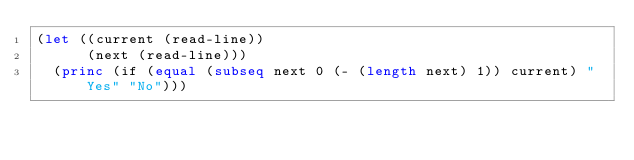Convert code to text. <code><loc_0><loc_0><loc_500><loc_500><_Lisp_>(let ((current (read-line))
      (next (read-line)))
  (princ (if (equal (subseq next 0 (- (length next) 1)) current) "Yes" "No")))</code> 